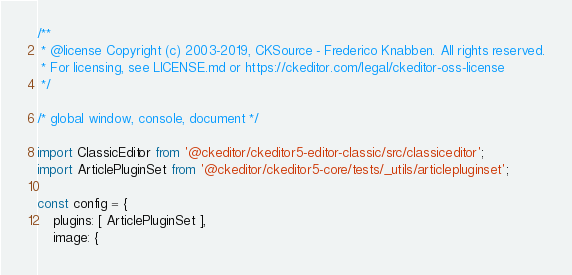Convert code to text. <code><loc_0><loc_0><loc_500><loc_500><_JavaScript_>/**
 * @license Copyright (c) 2003-2019, CKSource - Frederico Knabben. All rights reserved.
 * For licensing, see LICENSE.md or https://ckeditor.com/legal/ckeditor-oss-license
 */

/* global window, console, document */

import ClassicEditor from '@ckeditor/ckeditor5-editor-classic/src/classiceditor';
import ArticlePluginSet from '@ckeditor/ckeditor5-core/tests/_utils/articlepluginset';

const config = {
	plugins: [ ArticlePluginSet ],
	image: {</code> 